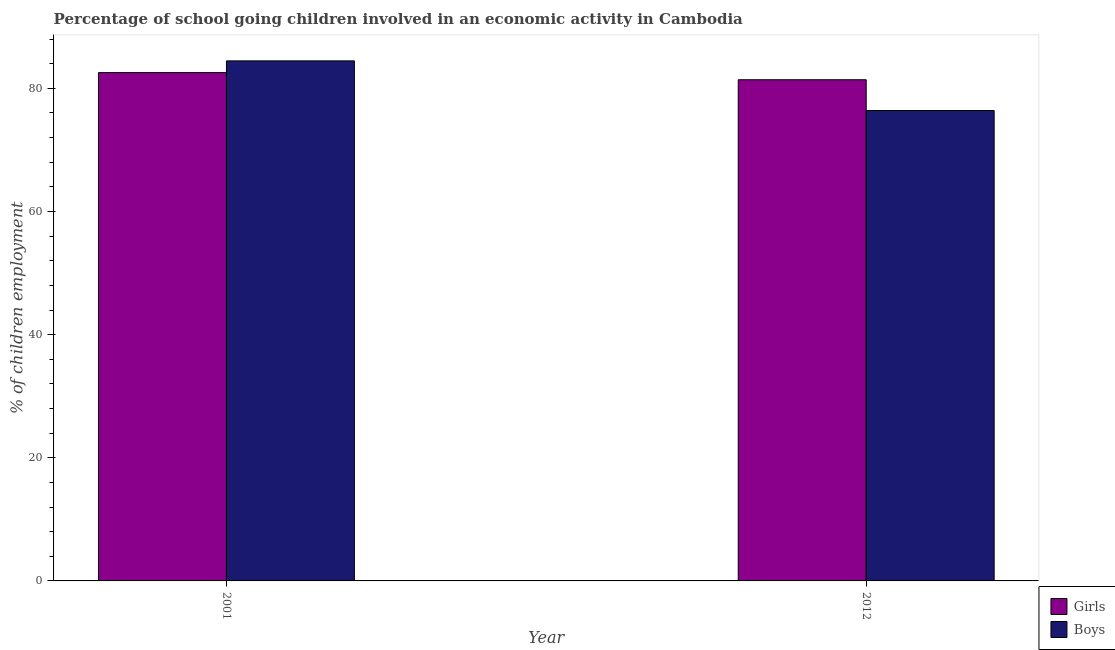How many different coloured bars are there?
Give a very brief answer. 2. How many groups of bars are there?
Offer a terse response. 2. In how many cases, is the number of bars for a given year not equal to the number of legend labels?
Give a very brief answer. 0. What is the percentage of school going boys in 2001?
Offer a terse response. 84.46. Across all years, what is the maximum percentage of school going girls?
Make the answer very short. 82.56. Across all years, what is the minimum percentage of school going boys?
Provide a succinct answer. 76.4. In which year was the percentage of school going girls minimum?
Make the answer very short. 2012. What is the total percentage of school going girls in the graph?
Provide a short and direct response. 163.96. What is the difference between the percentage of school going boys in 2001 and that in 2012?
Ensure brevity in your answer.  8.06. What is the difference between the percentage of school going boys in 2001 and the percentage of school going girls in 2012?
Ensure brevity in your answer.  8.06. What is the average percentage of school going boys per year?
Provide a short and direct response. 80.43. In how many years, is the percentage of school going boys greater than 68 %?
Make the answer very short. 2. What is the ratio of the percentage of school going girls in 2001 to that in 2012?
Your answer should be compact. 1.01. Is the percentage of school going girls in 2001 less than that in 2012?
Make the answer very short. No. In how many years, is the percentage of school going boys greater than the average percentage of school going boys taken over all years?
Provide a succinct answer. 1. What does the 1st bar from the left in 2001 represents?
Provide a short and direct response. Girls. What does the 2nd bar from the right in 2001 represents?
Provide a succinct answer. Girls. Are all the bars in the graph horizontal?
Provide a short and direct response. No. What is the difference between two consecutive major ticks on the Y-axis?
Offer a terse response. 20. Are the values on the major ticks of Y-axis written in scientific E-notation?
Keep it short and to the point. No. Does the graph contain grids?
Make the answer very short. No. Where does the legend appear in the graph?
Make the answer very short. Bottom right. How many legend labels are there?
Keep it short and to the point. 2. How are the legend labels stacked?
Make the answer very short. Vertical. What is the title of the graph?
Make the answer very short. Percentage of school going children involved in an economic activity in Cambodia. Does "Nonresident" appear as one of the legend labels in the graph?
Offer a terse response. No. What is the label or title of the Y-axis?
Provide a short and direct response. % of children employment. What is the % of children employment in Girls in 2001?
Ensure brevity in your answer.  82.56. What is the % of children employment in Boys in 2001?
Keep it short and to the point. 84.46. What is the % of children employment of Girls in 2012?
Your response must be concise. 81.4. What is the % of children employment in Boys in 2012?
Ensure brevity in your answer.  76.4. Across all years, what is the maximum % of children employment of Girls?
Your answer should be compact. 82.56. Across all years, what is the maximum % of children employment in Boys?
Make the answer very short. 84.46. Across all years, what is the minimum % of children employment in Girls?
Give a very brief answer. 81.4. Across all years, what is the minimum % of children employment in Boys?
Your answer should be compact. 76.4. What is the total % of children employment of Girls in the graph?
Provide a succinct answer. 163.96. What is the total % of children employment of Boys in the graph?
Your response must be concise. 160.86. What is the difference between the % of children employment of Girls in 2001 and that in 2012?
Offer a very short reply. 1.16. What is the difference between the % of children employment in Boys in 2001 and that in 2012?
Provide a short and direct response. 8.06. What is the difference between the % of children employment of Girls in 2001 and the % of children employment of Boys in 2012?
Keep it short and to the point. 6.16. What is the average % of children employment of Girls per year?
Your answer should be very brief. 81.98. What is the average % of children employment of Boys per year?
Ensure brevity in your answer.  80.43. In the year 2001, what is the difference between the % of children employment of Girls and % of children employment of Boys?
Your answer should be compact. -1.91. In the year 2012, what is the difference between the % of children employment of Girls and % of children employment of Boys?
Your answer should be compact. 5. What is the ratio of the % of children employment in Girls in 2001 to that in 2012?
Offer a terse response. 1.01. What is the ratio of the % of children employment of Boys in 2001 to that in 2012?
Ensure brevity in your answer.  1.11. What is the difference between the highest and the second highest % of children employment of Girls?
Your response must be concise. 1.16. What is the difference between the highest and the second highest % of children employment of Boys?
Keep it short and to the point. 8.06. What is the difference between the highest and the lowest % of children employment in Girls?
Your answer should be compact. 1.16. What is the difference between the highest and the lowest % of children employment of Boys?
Make the answer very short. 8.06. 